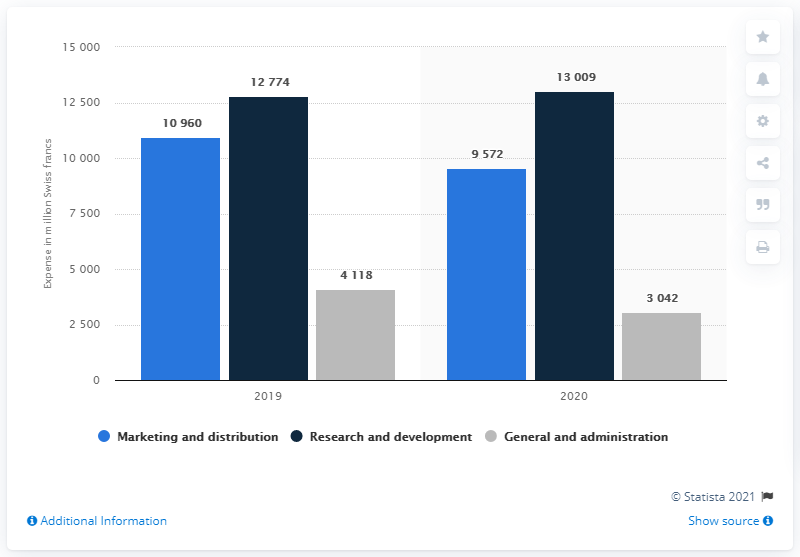Mention a couple of crucial points in this snapshot. In the year 2020, Roche spent 13,009 Swiss francs on research and development. The total of Marketing and distribution is 20532. Research and development had the highest value in 2020. 